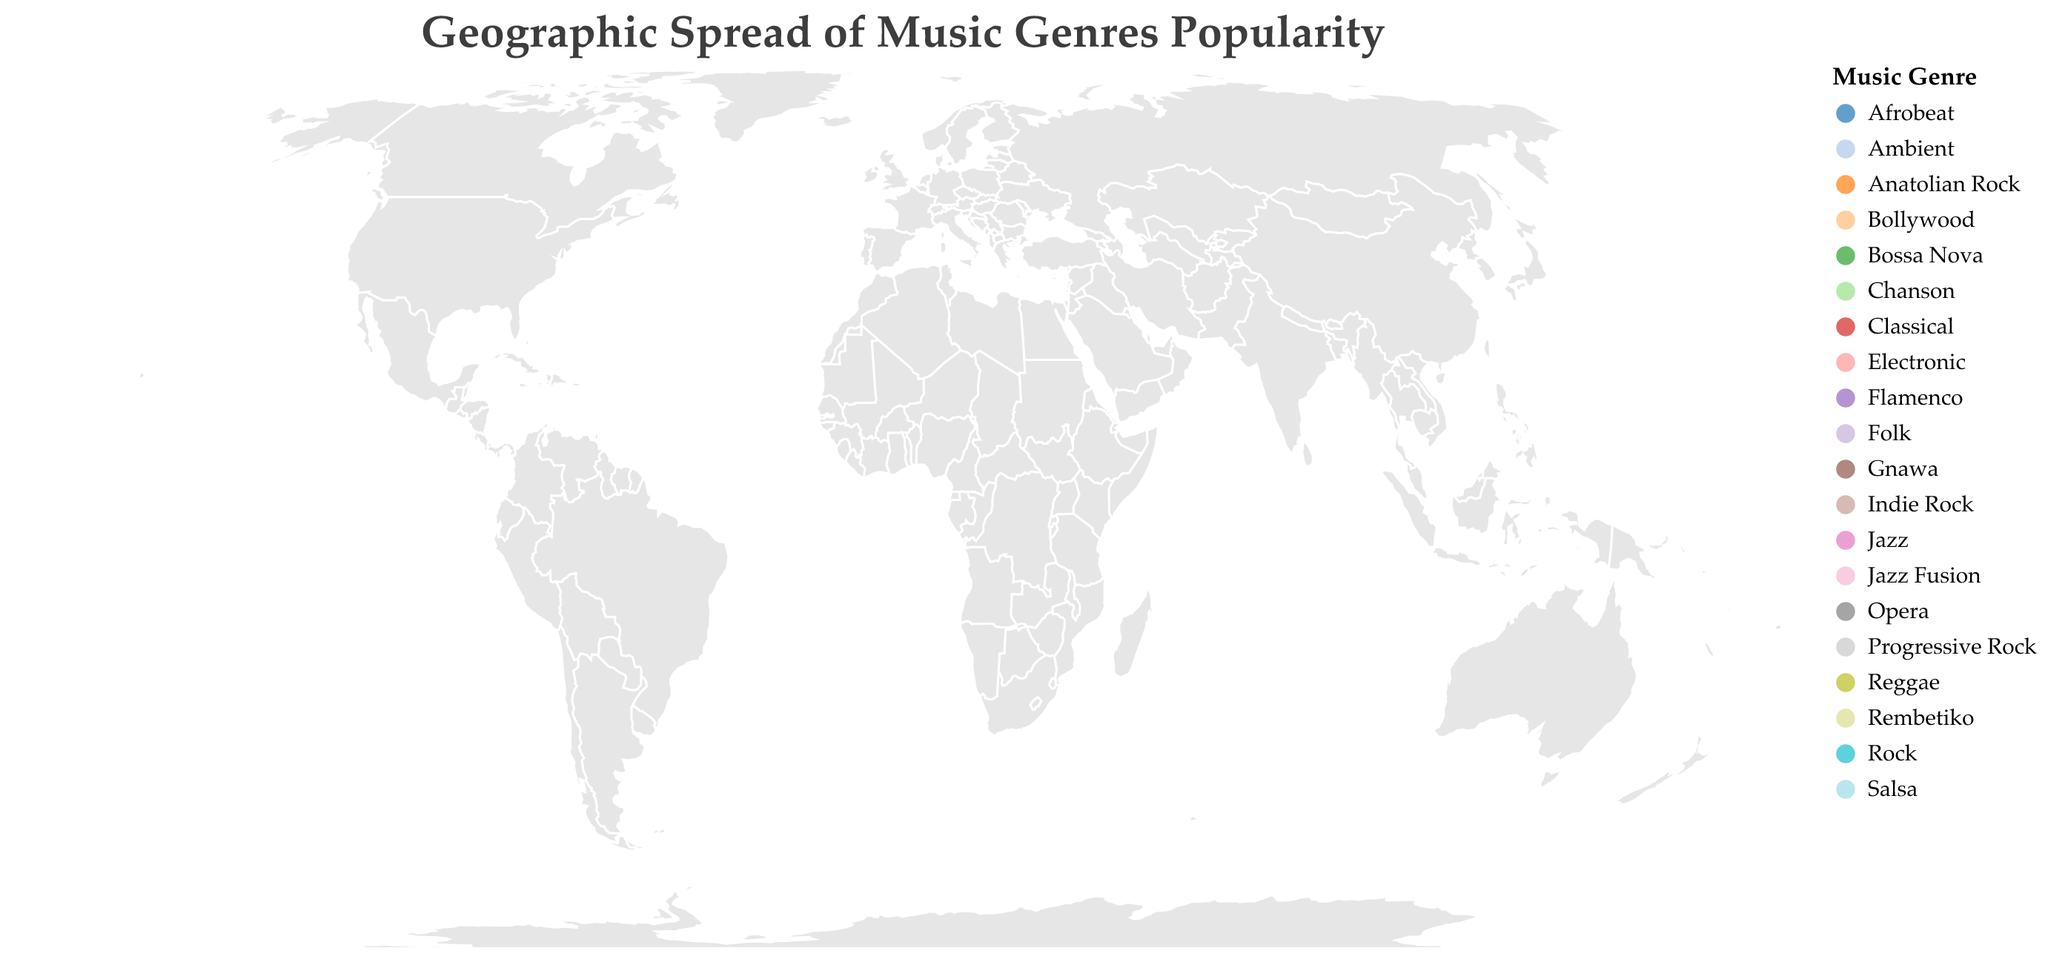What does the title of the plot indicate about the data? The title states "Geographic Spread of Music Genres Popularity," indicating that the plot visualizes the popularity of various music genres across different countries worldwide.
Answer: It shows global music genre popularity How many countries are represented in the plot? The plot includes data points corresponding to 20 different countries. Each point reflects a country marked by a circle.
Answer: 20 Which genre has the highest popularity, and in which country is it located? The plot shows that "Rock" has the highest popularity score of 92, and it is located in the United Kingdom.
Answer: Rock in the United Kingdom Compare the popularity scores of Jazz in the United States and Jazz Fusion in South Africa. Which is more popular? The popularity score for Jazz in the United States is 85, whereas for Jazz Fusion in South Africa, it is 62. Therefore, Jazz in the United States is more popular.
Answer: Jazz in the United States Which country has the lowest popularity score, and what is the genre? The plot shows that Greece has the lowest popularity score of 50 for the genre Rembetiko.
Answer: Greece has Rembetiko What's the average popularity score of the music genres in Europe (consider United Kingdom, Germany, France, Italy, Sweden, Greece, Spain, and Turkey)? Summing the popularity scores: Rock (92) + Electronic (70) + Chanson (65) + Opera (72) + Progressive Rock (73) + Rembetiko (50) + Flamenco (58) + Anatolian Rock (57) = 537. Dividing by the number of countries (8) gives 537/8 = 67.125.
Answer: 67.125 Which genres are uniquely popular in their respective countries (mentioned only once in the plot)? Genres like Chanson (France), Opera (Italy), Bossa Nova (Brazil), Reggae (Jamaica), Salsa (Cuba), Indie Rock (Australia), Flamenco (Spain), Afrobeat (Nigeria), Jazz Fusion (South Africa), Gnawa (Morocco), Anatolian Rock (Turkey), and Rembetiko (Greece) are mentioned only once and are unique to these countries in the plot.
Answer: Chanson, Opera, Bossa Nova, Reggae, Salsa, Indie Rock, Flamenco, Afrobeat, Jazz Fusion, Gnawa, Anatolian Rock, Rembetiko Is there a visual legend in the plot, and what does it represent? Yes, the plot has a visual legend that indicates different colors representing various music genres.
Answer: Yes, it represents music genres Which genre is the most popular in Asia according to the plot? The most popular genre in Asia is Classical with a popularity score of 78, located in Japan.
Answer: Classical in Japan 